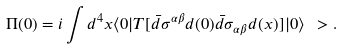<formula> <loc_0><loc_0><loc_500><loc_500>\Pi ( 0 ) = i \int d ^ { 4 } x \langle 0 | T [ \bar { d } \sigma ^ { \alpha \beta } d ( 0 ) \bar { d } \sigma _ { \alpha \beta } d ( x ) ] | 0 \rangle \ > .</formula> 